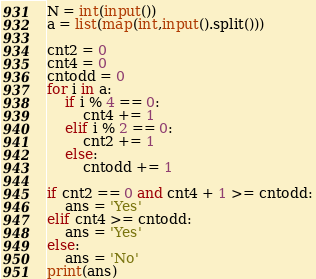Convert code to text. <code><loc_0><loc_0><loc_500><loc_500><_Python_>N = int(input())
a = list(map(int,input().split()))

cnt2 = 0
cnt4 = 0
cntodd = 0
for i in a:
    if i % 4 == 0:
        cnt4 += 1
    elif i % 2 == 0:
        cnt2 += 1
    else:
        cntodd += 1

if cnt2 == 0 and cnt4 + 1 >= cntodd:
    ans = 'Yes'
elif cnt4 >= cntodd:
    ans = 'Yes'
else:
    ans = 'No'
print(ans)    </code> 